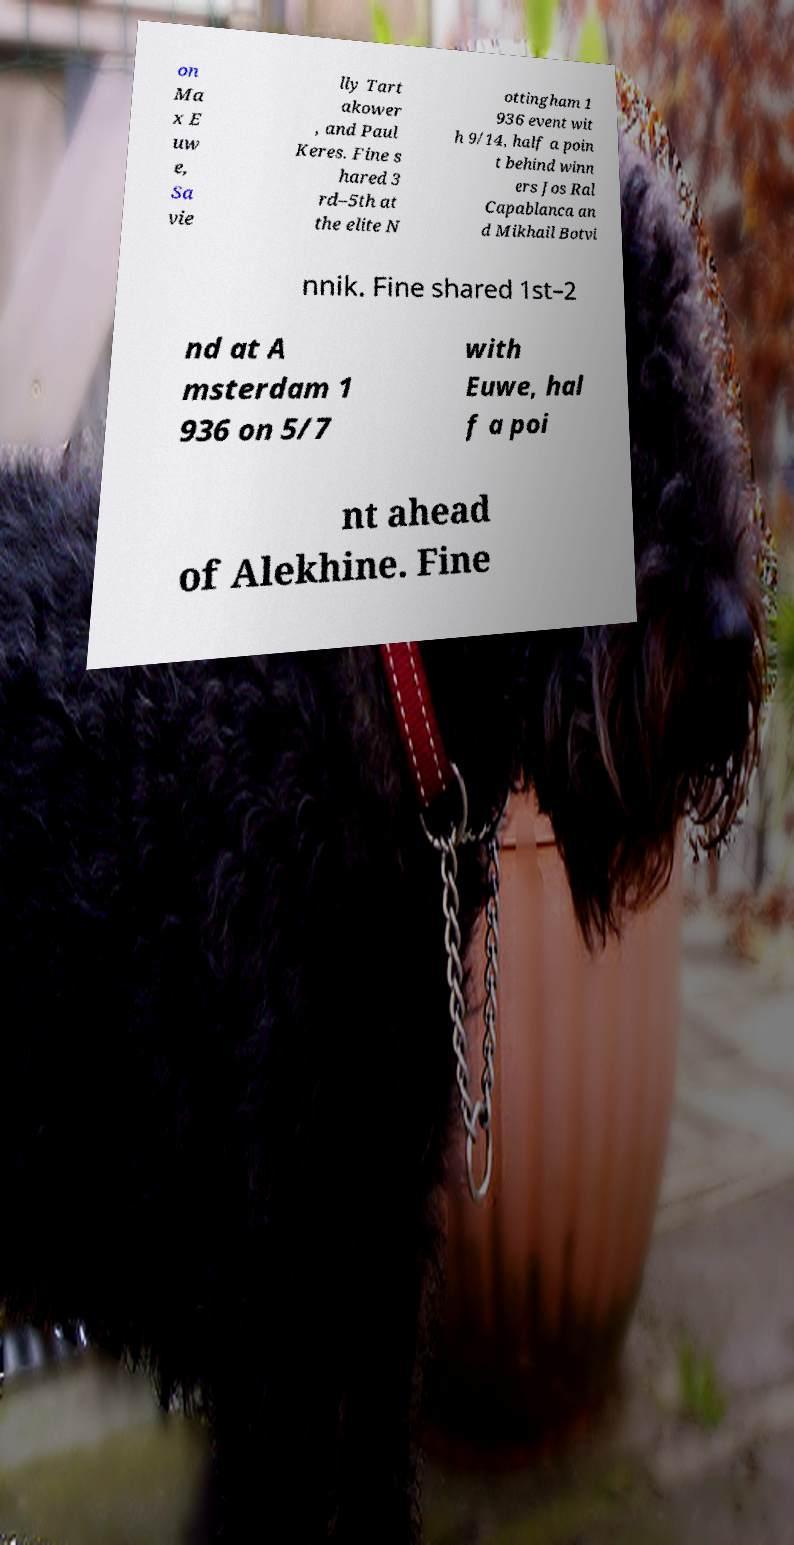Please read and relay the text visible in this image. What does it say? on Ma x E uw e, Sa vie lly Tart akower , and Paul Keres. Fine s hared 3 rd–5th at the elite N ottingham 1 936 event wit h 9/14, half a poin t behind winn ers Jos Ral Capablanca an d Mikhail Botvi nnik. Fine shared 1st–2 nd at A msterdam 1 936 on 5/7 with Euwe, hal f a poi nt ahead of Alekhine. Fine 